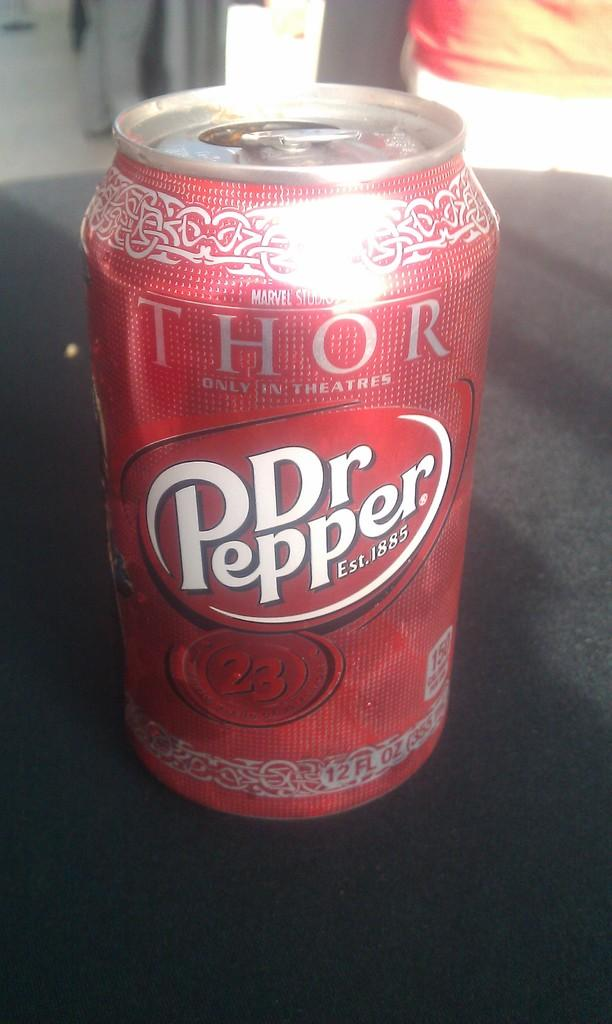Provide a one-sentence caption for the provided image. Dr. Pepper is advertising the movie Thor on their 12 oz cans. 